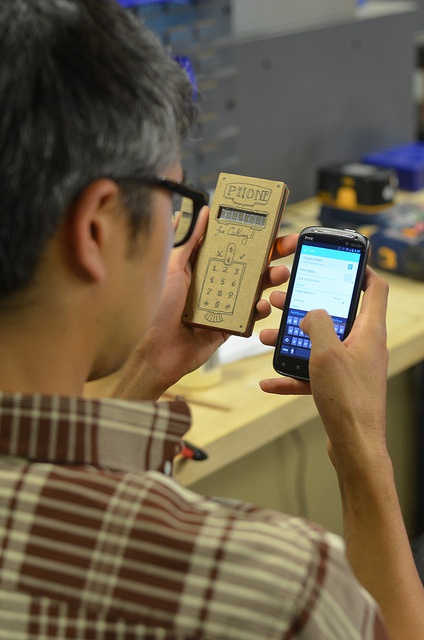Describe the objects in this image and their specific colors. I can see people in black, maroon, and gray tones and cell phone in black, lightblue, cyan, and navy tones in this image. 